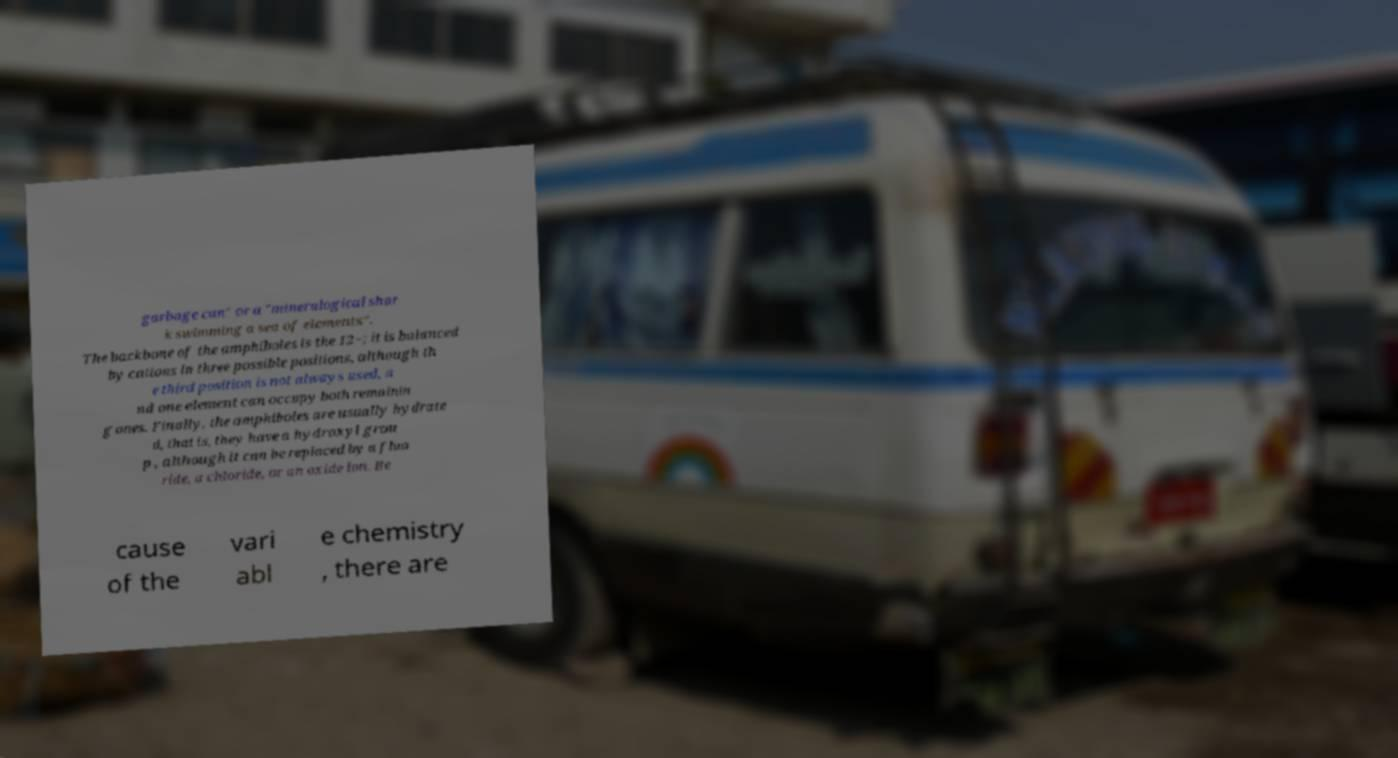Could you assist in decoding the text presented in this image and type it out clearly? garbage can" or a "mineralogical shar k swimming a sea of elements". The backbone of the amphiboles is the 12−; it is balanced by cations in three possible positions, although th e third position is not always used, a nd one element can occupy both remainin g ones. Finally, the amphiboles are usually hydrate d, that is, they have a hydroxyl grou p , although it can be replaced by a fluo ride, a chloride, or an oxide ion. Be cause of the vari abl e chemistry , there are 